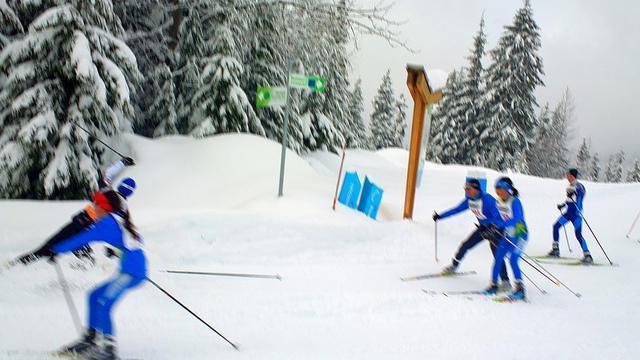What are these people doing with each other?
Select the accurate response from the four choices given to answer the question.
Options: Resting, singing, yelling, racing. Racing. 